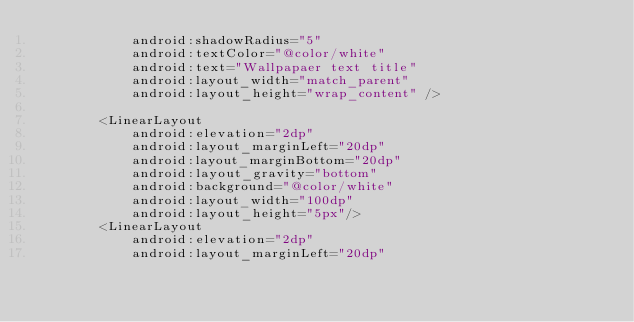Convert code to text. <code><loc_0><loc_0><loc_500><loc_500><_XML_>            android:shadowRadius="5"
            android:textColor="@color/white"
            android:text="Wallpapaer text title"
            android:layout_width="match_parent"
            android:layout_height="wrap_content" />

        <LinearLayout
            android:elevation="2dp"
            android:layout_marginLeft="20dp"
            android:layout_marginBottom="20dp"
            android:layout_gravity="bottom"
            android:background="@color/white"
            android:layout_width="100dp"
            android:layout_height="5px"/>
        <LinearLayout
            android:elevation="2dp"
            android:layout_marginLeft="20dp"</code> 